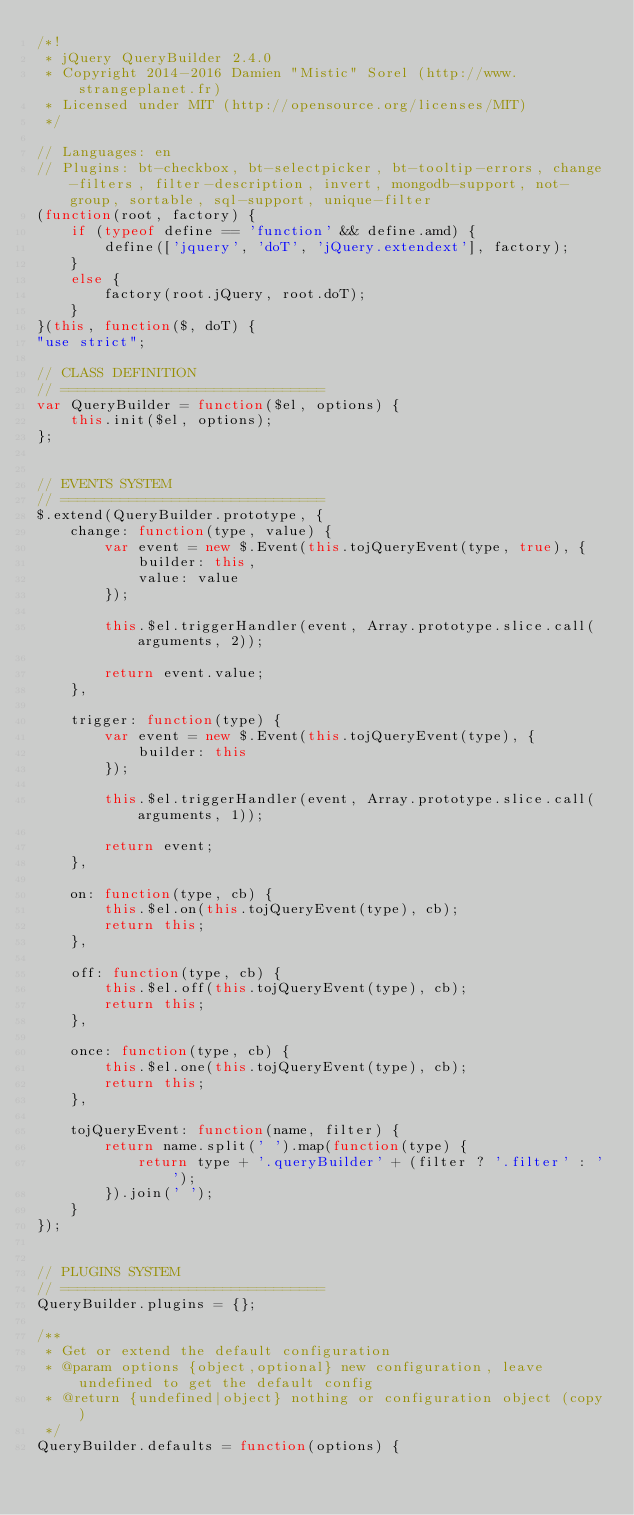Convert code to text. <code><loc_0><loc_0><loc_500><loc_500><_JavaScript_>/*!
 * jQuery QueryBuilder 2.4.0
 * Copyright 2014-2016 Damien "Mistic" Sorel (http://www.strangeplanet.fr)
 * Licensed under MIT (http://opensource.org/licenses/MIT)
 */

// Languages: en
// Plugins: bt-checkbox, bt-selectpicker, bt-tooltip-errors, change-filters, filter-description, invert, mongodb-support, not-group, sortable, sql-support, unique-filter
(function(root, factory) {
    if (typeof define == 'function' && define.amd) {
        define(['jquery', 'doT', 'jQuery.extendext'], factory);
    }
    else {
        factory(root.jQuery, root.doT);
    }
}(this, function($, doT) {
"use strict";

// CLASS DEFINITION
// ===============================
var QueryBuilder = function($el, options) {
    this.init($el, options);
};


// EVENTS SYSTEM
// ===============================
$.extend(QueryBuilder.prototype, {
    change: function(type, value) {
        var event = new $.Event(this.tojQueryEvent(type, true), {
            builder: this,
            value: value
        });

        this.$el.triggerHandler(event, Array.prototype.slice.call(arguments, 2));

        return event.value;
    },

    trigger: function(type) {
        var event = new $.Event(this.tojQueryEvent(type), {
            builder: this
        });

        this.$el.triggerHandler(event, Array.prototype.slice.call(arguments, 1));

        return event;
    },

    on: function(type, cb) {
        this.$el.on(this.tojQueryEvent(type), cb);
        return this;
    },

    off: function(type, cb) {
        this.$el.off(this.tojQueryEvent(type), cb);
        return this;
    },

    once: function(type, cb) {
        this.$el.one(this.tojQueryEvent(type), cb);
        return this;
    },

    tojQueryEvent: function(name, filter) {
        return name.split(' ').map(function(type) {
            return type + '.queryBuilder' + (filter ? '.filter' : '');
        }).join(' ');
    }
});


// PLUGINS SYSTEM
// ===============================
QueryBuilder.plugins = {};

/**
 * Get or extend the default configuration
 * @param options {object,optional} new configuration, leave undefined to get the default config
 * @return {undefined|object} nothing or configuration object (copy)
 */
QueryBuilder.defaults = function(options) {</code> 